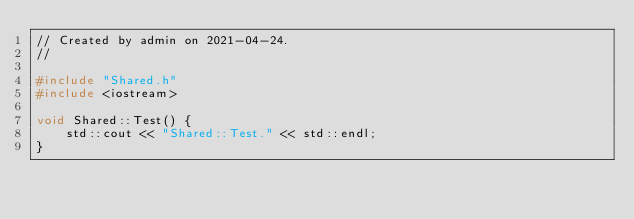<code> <loc_0><loc_0><loc_500><loc_500><_C++_>// Created by admin on 2021-04-24.
//

#include "Shared.h"
#include <iostream>

void Shared::Test() {
    std::cout << "Shared::Test." << std::endl;
}</code> 